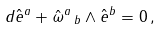Convert formula to latex. <formula><loc_0><loc_0><loc_500><loc_500>d \hat { e } ^ { a } + \hat { \omega } ^ { a } \, _ { b } \wedge \hat { e } ^ { b } = 0 \, ,</formula> 